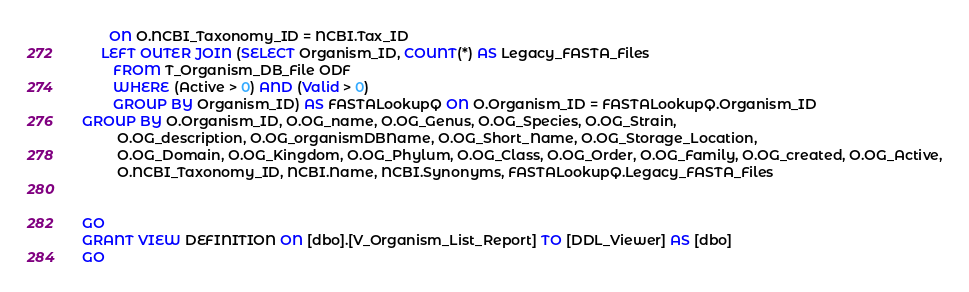<code> <loc_0><loc_0><loc_500><loc_500><_SQL_>	   ON O.NCBI_Taxonomy_ID = NCBI.Tax_ID
	 LEFT OUTER JOIN (SELECT Organism_ID, COUNT(*) AS Legacy_FASTA_Files
		FROM T_Organism_DB_File ODF
		WHERE (Active > 0) AND (Valid > 0)
		GROUP BY Organism_ID) AS FASTALookupQ ON O.Organism_ID = FASTALookupQ.Organism_ID
GROUP BY O.Organism_ID, O.OG_name, O.OG_Genus, O.OG_Species, O.OG_Strain, 
         O.OG_description, O.OG_organismDBName, O.OG_Short_Name, O.OG_Storage_Location,
         O.OG_Domain, O.OG_Kingdom, O.OG_Phylum, O.OG_Class, O.OG_Order, O.OG_Family, O.OG_created, O.OG_Active,
		 O.NCBI_Taxonomy_ID, NCBI.Name, NCBI.Synonyms, FASTALookupQ.Legacy_FASTA_Files


GO
GRANT VIEW DEFINITION ON [dbo].[V_Organism_List_Report] TO [DDL_Viewer] AS [dbo]
GO
</code> 